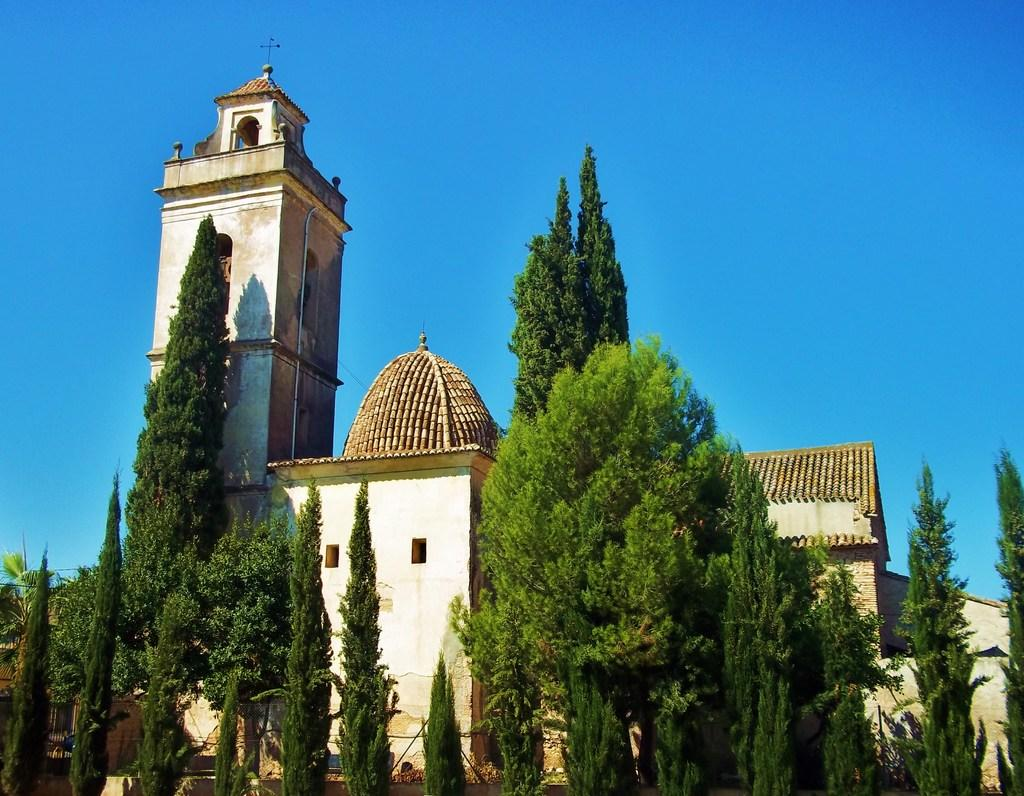What type of structures can be seen in the image? There are buildings in the image. What feature is visible on the buildings? There are windows visible in the image. What type of vegetation is present in the image? There are green trees in the image. What color is the sky in the image? The sky is blue in color. Where is the faucet located in the image? There is no faucet present in the image. What type of musical instrument is being played in the image? There is no musical instrument or indication of music being played in the image. 